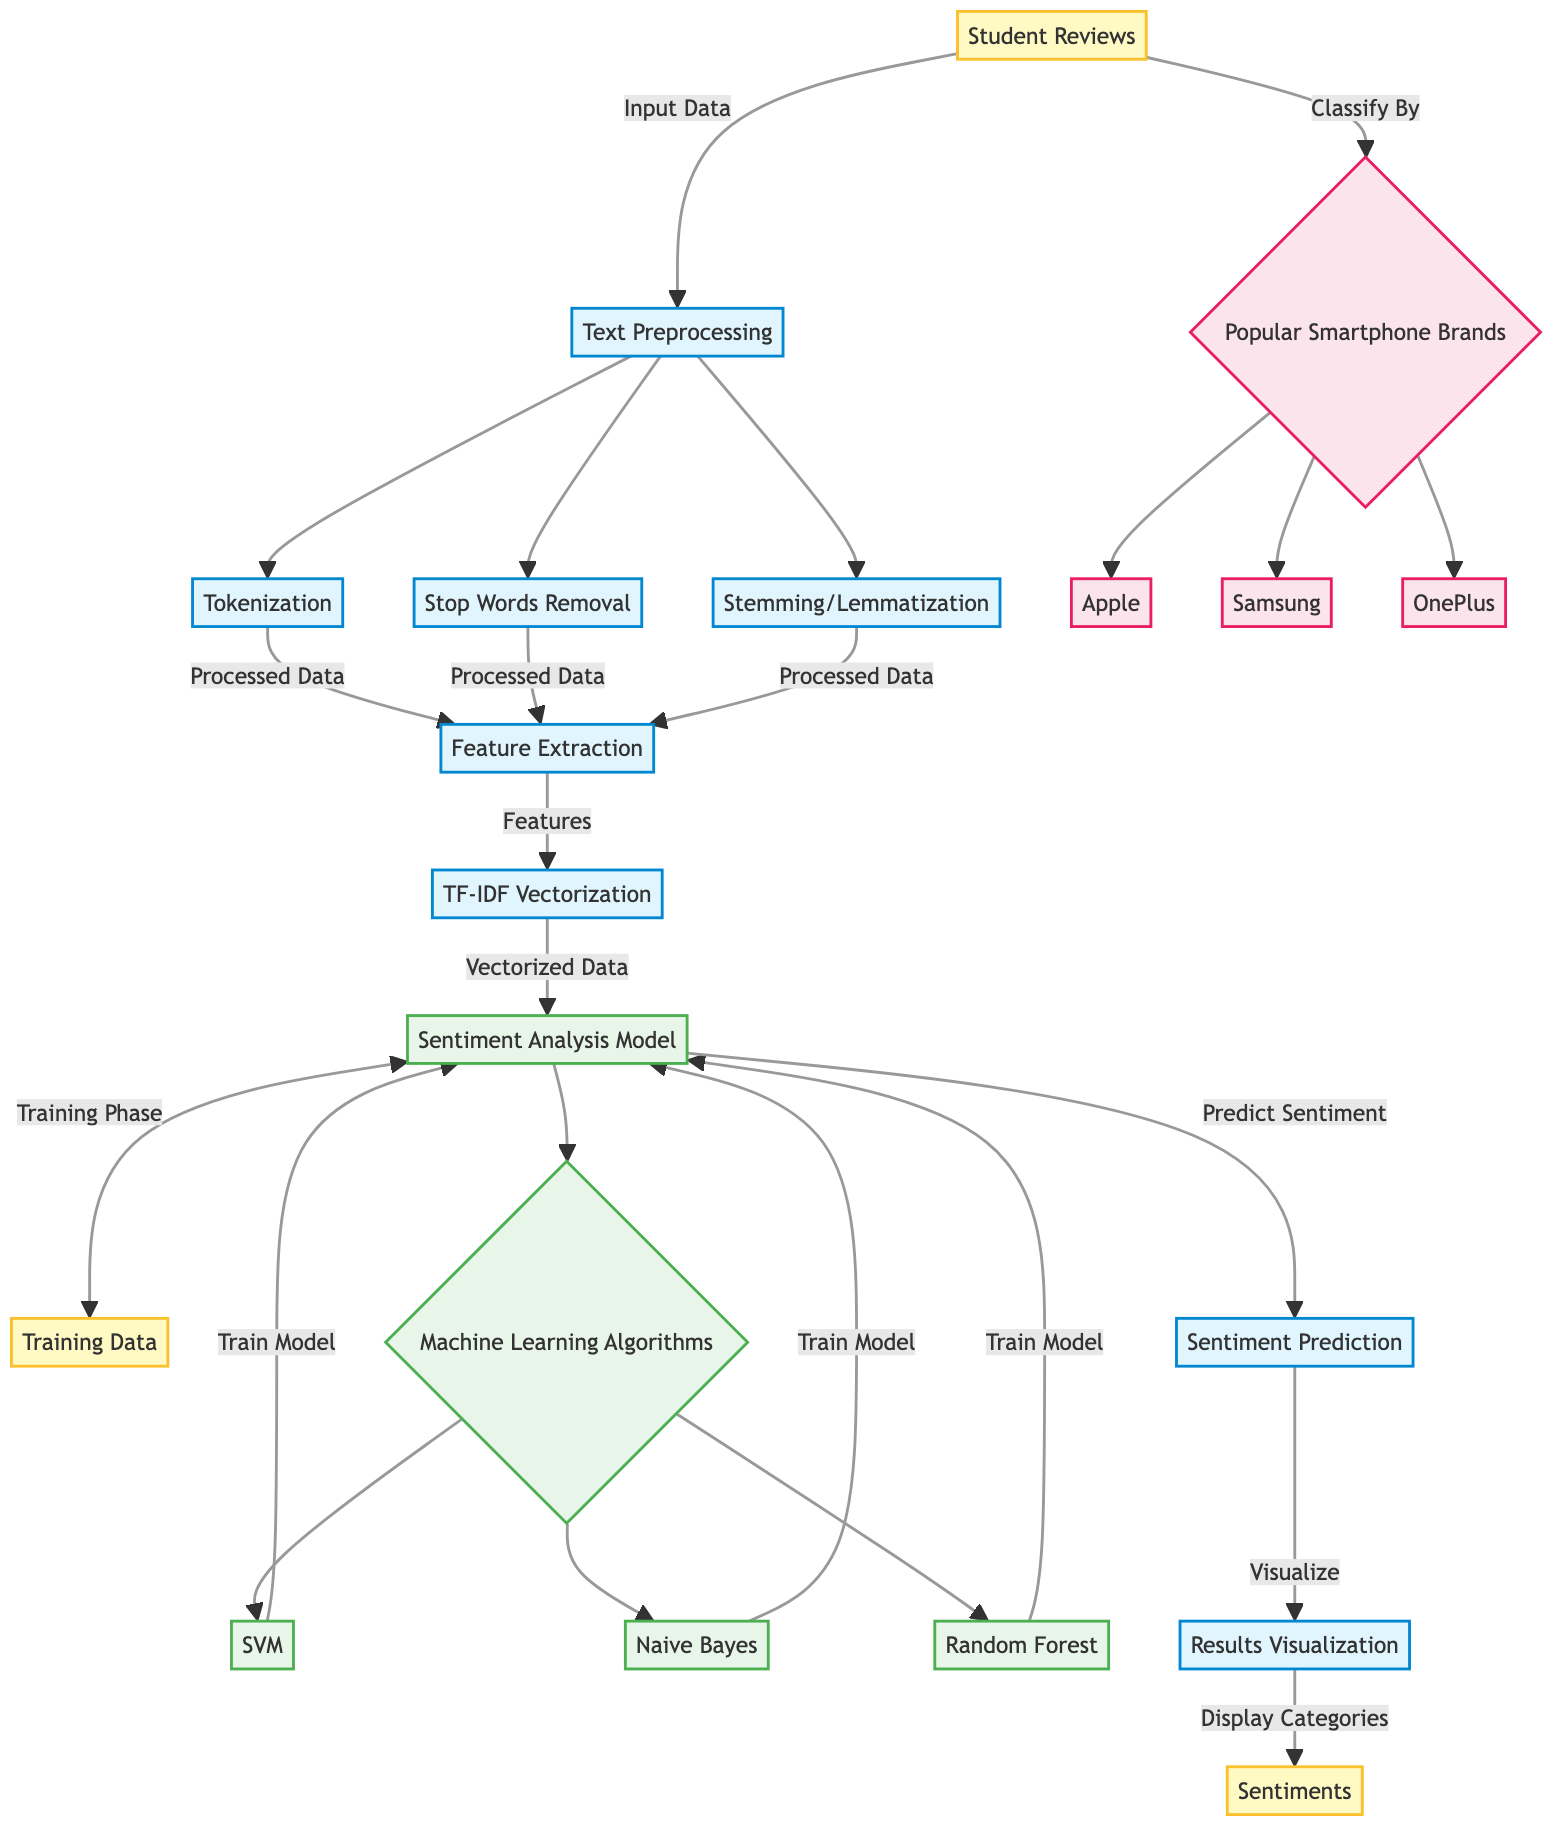What is the first step in the sentiment analysis process? The diagram shows that the first step is "Student Reviews," which indicates that the raw data inputs come from students' feedback on smartphone brands.
Answer: Student Reviews How many machine learning algorithms are used in this diagram? The diagram features three machine learning algorithms: Support Vector Machine, Naive Bayes, and Random Forest, indicating the options available for analysis.
Answer: Three What are the popular smartphone brands listed in the diagram? The diagram lists three popular smartphone brands: Apple, Samsung, and OnePlus, which represent the brands that student reviews pertain to.
Answer: Apple, Samsung, OnePlus What is the output of the sentiment analysis model? The diagram indicates that the output of the sentiment analysis model is "Sentiment Prediction," which implies the model's primary function to derive sentiment values from input data.
Answer: Sentiment Prediction Which step follows after the tokenization process? According to the diagram's flow, after "Tokenization," the next step is "Stop Words Removal," indicating the sequential nature of the preprocessing tasks.
Answer: Stop Words Removal What type of data is processed in the feature extraction step? The feature extraction step receives "Processed Data" as input, which indicates that it works on data that has already been cleaned and prepared through the preceding steps.
Answer: Processed Data What does TF-IDF stand for, as indicated in the diagram? The terminology TF-IDF stands for "Term Frequency-Inverse Document Frequency," as inferred from the vectorization process of converting text data into a numerical format suitable for modeling.
Answer: Term Frequency-Inverse Document Frequency How is the sentiment data visualized in the diagram? The diagram shows that "Results Visualization" is the step where sentiment data is visualized, confirming that the model's output is displayed in a human-readable format.
Answer: Results Visualization What happens during the "Training Phase"? During the "Training Phase," the sentiment analysis model is trained using "Training Data," allowing it to learn patterns and features from student reviews to make accurate predictions.
Answer: Training Data 